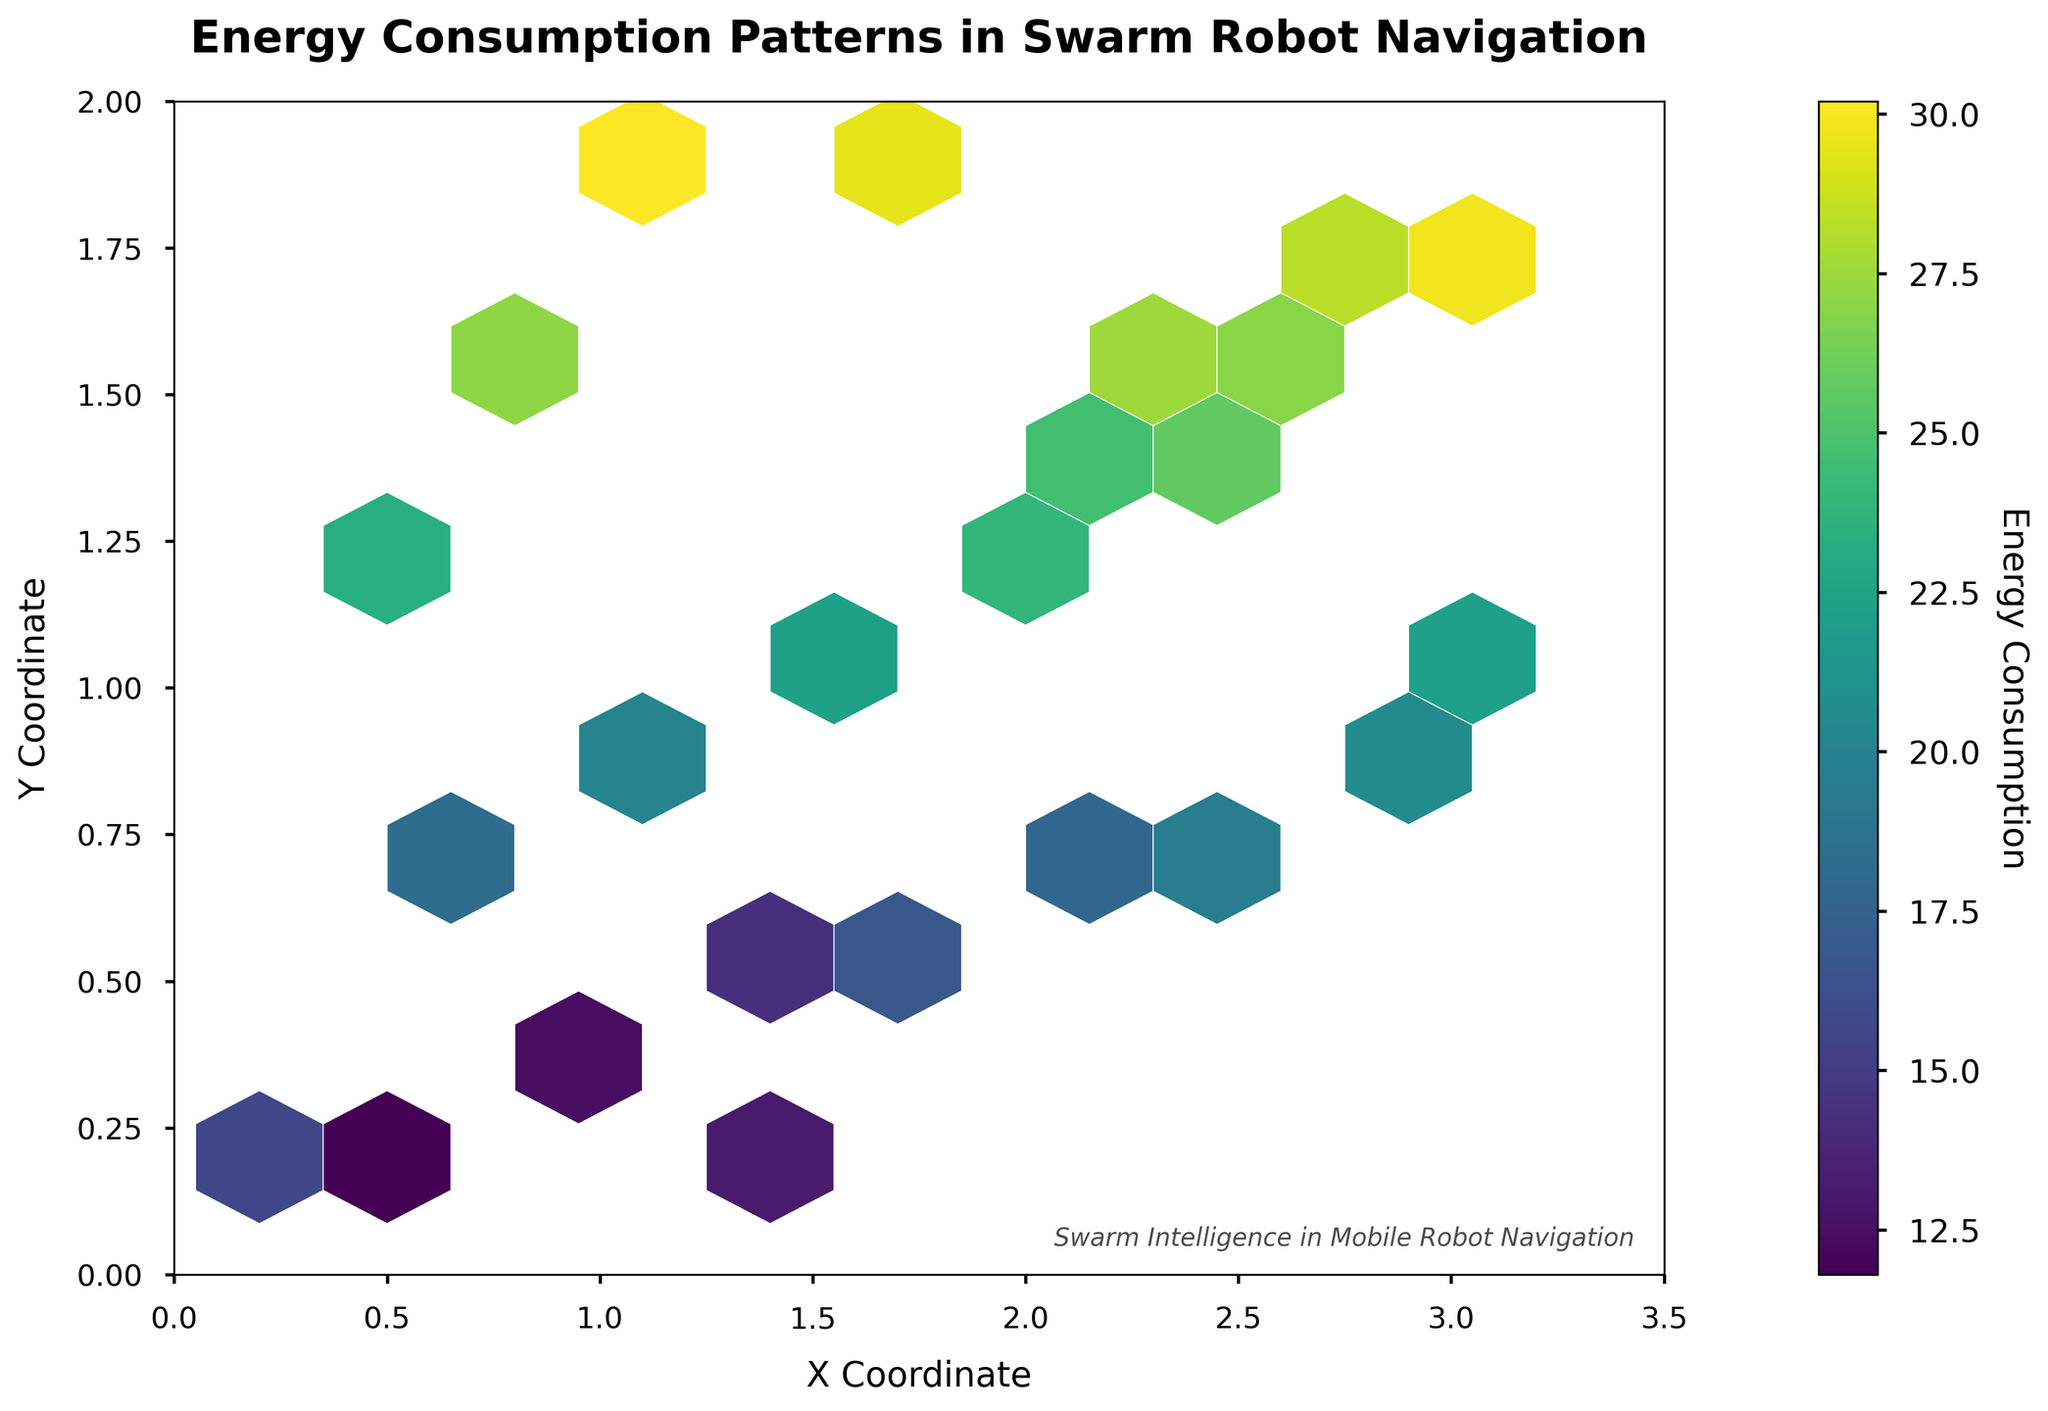What is the title of the plot? The title of the plot is displayed at the top of the figure. It reads "Energy Consumption Patterns in Swarm Robot Navigation."
Answer: Energy Consumption Patterns in Swarm Robot Navigation What variable is represented on the x-axis? The x-axis is labeled "X Coordinate," which indicates that it represents the X Coordinate variable.
Answer: X Coordinate What does the color indicate in the hexbin plot? The color in the hexbin plot represents the "Energy Consumption" values. Darker colors indicate higher energy consumption.
Answer: Energy Consumption What is the range of the y-axis? The y-axis has tick marks indicating its range. The range is from 0 to 2.
Answer: 0 to 2 Which area shows the highest energy consumption? The highest energy consumption is represented by the darkest color in the hexbin plot. The darkest hexes appear around the coordinates (1, 1.8), indicating this area has the highest energy consumption.
Answer: Around (1, 1.8) How is the grid size of the hexagons determined visually? Visually, the hexagons' grid size can be estimated by noting the number of rows and columns of hexagons. It appears to be a 10x10 grid.
Answer: 10x10 grid Which area shows the lowest energy consumption on the plot? The lowest energy consumption is represented by the lightest colors in the hexbin plot. The lightest hexes appear around the coordinates (0.6, 0.2), indicating this area has the lowest energy consumption.
Answer: Around (0.6, 0.2) Compare the energy consumption at coordinates (1.5, 1.1) and (2.7, 1.5). Which one is higher? By comparing the colors of the hexes at these coordinates, it is evident that the hex at (2.7, 1.5) is darker, indicating higher energy consumption compared to the hex at (1.5, 1.1).
Answer: (2.7, 1.5) What is the color gradient used in the hexbin plot? The plot uses a viridis color map, which transitions from yellow for lower values to green and then to blue for higher values.
Answer: Viridis color map What does the color bar indicate in the plot? The color bar on the side of the plot indicates the range and scale of energy consumption values associated with the colors used in the hexbin plot. It provides a reference to interpret the colors in terms of energy consumption levels.
Answer: Scale of energy consumption values 